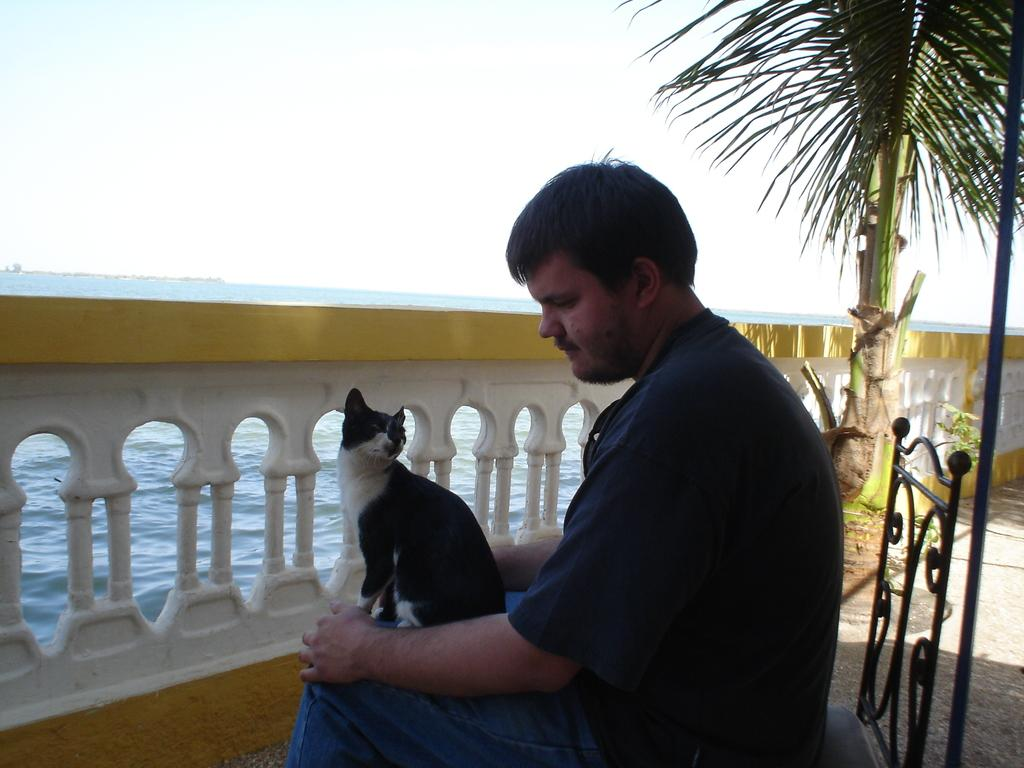Who is present in the image? There is a man in the image. What is the man doing in the image? The man is sitting on a chair. Is there any animal present in the image? Yes, there is a cat on the man. What can be seen in the background of the image? There is a fence, a tree, and water visible in the image. How many women are present in the image? There are no women present in the image; it only features a man and a cat. Is there any rabbit visible in the image? No, there is no rabbit present in the image. 